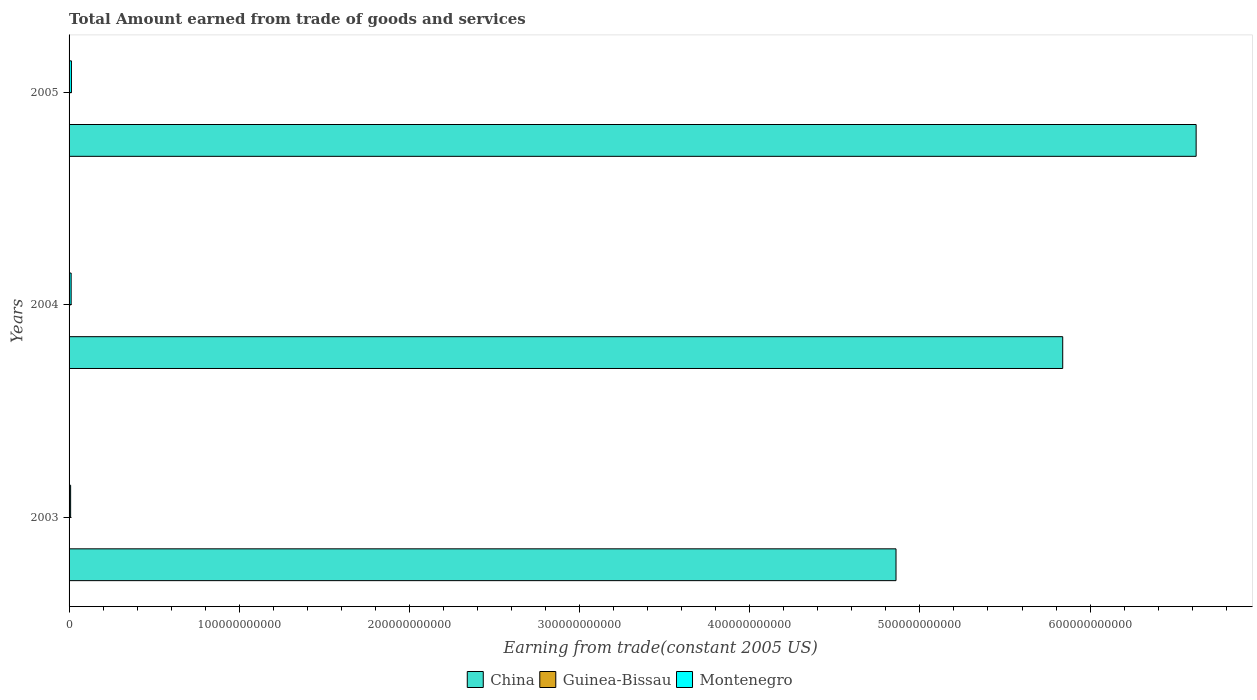How many groups of bars are there?
Give a very brief answer. 3. How many bars are there on the 3rd tick from the bottom?
Give a very brief answer. 3. In how many cases, is the number of bars for a given year not equal to the number of legend labels?
Your response must be concise. 0. What is the total amount earned by trading goods and services in Montenegro in 2005?
Your answer should be very brief. 1.38e+09. Across all years, what is the maximum total amount earned by trading goods and services in China?
Offer a terse response. 6.62e+11. Across all years, what is the minimum total amount earned by trading goods and services in Montenegro?
Make the answer very short. 9.18e+08. What is the total total amount earned by trading goods and services in Montenegro in the graph?
Offer a terse response. 3.51e+09. What is the difference between the total amount earned by trading goods and services in Montenegro in 2003 and that in 2004?
Offer a terse response. -2.95e+08. What is the difference between the total amount earned by trading goods and services in China in 2004 and the total amount earned by trading goods and services in Montenegro in 2003?
Provide a short and direct response. 5.83e+11. What is the average total amount earned by trading goods and services in Montenegro per year?
Keep it short and to the point. 1.17e+09. In the year 2003, what is the difference between the total amount earned by trading goods and services in China and total amount earned by trading goods and services in Montenegro?
Keep it short and to the point. 4.85e+11. What is the ratio of the total amount earned by trading goods and services in China in 2003 to that in 2004?
Offer a terse response. 0.83. Is the total amount earned by trading goods and services in Montenegro in 2004 less than that in 2005?
Offer a terse response. Yes. What is the difference between the highest and the second highest total amount earned by trading goods and services in Guinea-Bissau?
Offer a very short reply. 2.99e+06. What is the difference between the highest and the lowest total amount earned by trading goods and services in China?
Offer a very short reply. 1.76e+11. In how many years, is the total amount earned by trading goods and services in Guinea-Bissau greater than the average total amount earned by trading goods and services in Guinea-Bissau taken over all years?
Offer a terse response. 2. What does the 2nd bar from the top in 2005 represents?
Keep it short and to the point. Guinea-Bissau. What does the 3rd bar from the bottom in 2004 represents?
Offer a very short reply. Montenegro. Are all the bars in the graph horizontal?
Keep it short and to the point. Yes. What is the difference between two consecutive major ticks on the X-axis?
Your response must be concise. 1.00e+11. Where does the legend appear in the graph?
Offer a very short reply. Bottom center. How many legend labels are there?
Keep it short and to the point. 3. How are the legend labels stacked?
Offer a terse response. Horizontal. What is the title of the graph?
Provide a succinct answer. Total Amount earned from trade of goods and services. What is the label or title of the X-axis?
Provide a short and direct response. Earning from trade(constant 2005 US). What is the label or title of the Y-axis?
Give a very brief answer. Years. What is the Earning from trade(constant 2005 US) in China in 2003?
Provide a succinct answer. 4.86e+11. What is the Earning from trade(constant 2005 US) in Guinea-Bissau in 2003?
Provide a short and direct response. 1.31e+08. What is the Earning from trade(constant 2005 US) in Montenegro in 2003?
Ensure brevity in your answer.  9.18e+08. What is the Earning from trade(constant 2005 US) in China in 2004?
Your response must be concise. 5.84e+11. What is the Earning from trade(constant 2005 US) of Guinea-Bissau in 2004?
Offer a terse response. 1.71e+08. What is the Earning from trade(constant 2005 US) of Montenegro in 2004?
Ensure brevity in your answer.  1.21e+09. What is the Earning from trade(constant 2005 US) of China in 2005?
Your answer should be very brief. 6.62e+11. What is the Earning from trade(constant 2005 US) in Guinea-Bissau in 2005?
Ensure brevity in your answer.  1.68e+08. What is the Earning from trade(constant 2005 US) of Montenegro in 2005?
Offer a terse response. 1.38e+09. Across all years, what is the maximum Earning from trade(constant 2005 US) in China?
Provide a succinct answer. 6.62e+11. Across all years, what is the maximum Earning from trade(constant 2005 US) in Guinea-Bissau?
Your answer should be compact. 1.71e+08. Across all years, what is the maximum Earning from trade(constant 2005 US) of Montenegro?
Provide a succinct answer. 1.38e+09. Across all years, what is the minimum Earning from trade(constant 2005 US) of China?
Offer a terse response. 4.86e+11. Across all years, what is the minimum Earning from trade(constant 2005 US) of Guinea-Bissau?
Offer a very short reply. 1.31e+08. Across all years, what is the minimum Earning from trade(constant 2005 US) in Montenegro?
Keep it short and to the point. 9.18e+08. What is the total Earning from trade(constant 2005 US) in China in the graph?
Your answer should be very brief. 1.73e+12. What is the total Earning from trade(constant 2005 US) of Guinea-Bissau in the graph?
Provide a succinct answer. 4.70e+08. What is the total Earning from trade(constant 2005 US) of Montenegro in the graph?
Provide a succinct answer. 3.51e+09. What is the difference between the Earning from trade(constant 2005 US) of China in 2003 and that in 2004?
Keep it short and to the point. -9.80e+1. What is the difference between the Earning from trade(constant 2005 US) of Guinea-Bissau in 2003 and that in 2004?
Your answer should be compact. -3.94e+07. What is the difference between the Earning from trade(constant 2005 US) in Montenegro in 2003 and that in 2004?
Give a very brief answer. -2.95e+08. What is the difference between the Earning from trade(constant 2005 US) in China in 2003 and that in 2005?
Your response must be concise. -1.76e+11. What is the difference between the Earning from trade(constant 2005 US) in Guinea-Bissau in 2003 and that in 2005?
Provide a short and direct response. -3.64e+07. What is the difference between the Earning from trade(constant 2005 US) in Montenegro in 2003 and that in 2005?
Your answer should be compact. -4.61e+08. What is the difference between the Earning from trade(constant 2005 US) of China in 2004 and that in 2005?
Provide a short and direct response. -7.84e+1. What is the difference between the Earning from trade(constant 2005 US) in Guinea-Bissau in 2004 and that in 2005?
Offer a very short reply. 2.99e+06. What is the difference between the Earning from trade(constant 2005 US) in Montenegro in 2004 and that in 2005?
Your answer should be compact. -1.66e+08. What is the difference between the Earning from trade(constant 2005 US) in China in 2003 and the Earning from trade(constant 2005 US) in Guinea-Bissau in 2004?
Keep it short and to the point. 4.86e+11. What is the difference between the Earning from trade(constant 2005 US) of China in 2003 and the Earning from trade(constant 2005 US) of Montenegro in 2004?
Make the answer very short. 4.85e+11. What is the difference between the Earning from trade(constant 2005 US) of Guinea-Bissau in 2003 and the Earning from trade(constant 2005 US) of Montenegro in 2004?
Offer a very short reply. -1.08e+09. What is the difference between the Earning from trade(constant 2005 US) of China in 2003 and the Earning from trade(constant 2005 US) of Guinea-Bissau in 2005?
Offer a terse response. 4.86e+11. What is the difference between the Earning from trade(constant 2005 US) of China in 2003 and the Earning from trade(constant 2005 US) of Montenegro in 2005?
Your answer should be compact. 4.85e+11. What is the difference between the Earning from trade(constant 2005 US) of Guinea-Bissau in 2003 and the Earning from trade(constant 2005 US) of Montenegro in 2005?
Give a very brief answer. -1.25e+09. What is the difference between the Earning from trade(constant 2005 US) in China in 2004 and the Earning from trade(constant 2005 US) in Guinea-Bissau in 2005?
Provide a short and direct response. 5.84e+11. What is the difference between the Earning from trade(constant 2005 US) in China in 2004 and the Earning from trade(constant 2005 US) in Montenegro in 2005?
Offer a very short reply. 5.83e+11. What is the difference between the Earning from trade(constant 2005 US) of Guinea-Bissau in 2004 and the Earning from trade(constant 2005 US) of Montenegro in 2005?
Give a very brief answer. -1.21e+09. What is the average Earning from trade(constant 2005 US) in China per year?
Offer a very short reply. 5.77e+11. What is the average Earning from trade(constant 2005 US) in Guinea-Bissau per year?
Keep it short and to the point. 1.57e+08. What is the average Earning from trade(constant 2005 US) of Montenegro per year?
Your answer should be very brief. 1.17e+09. In the year 2003, what is the difference between the Earning from trade(constant 2005 US) in China and Earning from trade(constant 2005 US) in Guinea-Bissau?
Give a very brief answer. 4.86e+11. In the year 2003, what is the difference between the Earning from trade(constant 2005 US) in China and Earning from trade(constant 2005 US) in Montenegro?
Ensure brevity in your answer.  4.85e+11. In the year 2003, what is the difference between the Earning from trade(constant 2005 US) in Guinea-Bissau and Earning from trade(constant 2005 US) in Montenegro?
Offer a terse response. -7.86e+08. In the year 2004, what is the difference between the Earning from trade(constant 2005 US) of China and Earning from trade(constant 2005 US) of Guinea-Bissau?
Your response must be concise. 5.84e+11. In the year 2004, what is the difference between the Earning from trade(constant 2005 US) in China and Earning from trade(constant 2005 US) in Montenegro?
Provide a succinct answer. 5.83e+11. In the year 2004, what is the difference between the Earning from trade(constant 2005 US) in Guinea-Bissau and Earning from trade(constant 2005 US) in Montenegro?
Offer a very short reply. -1.04e+09. In the year 2005, what is the difference between the Earning from trade(constant 2005 US) of China and Earning from trade(constant 2005 US) of Guinea-Bissau?
Your answer should be compact. 6.62e+11. In the year 2005, what is the difference between the Earning from trade(constant 2005 US) in China and Earning from trade(constant 2005 US) in Montenegro?
Ensure brevity in your answer.  6.61e+11. In the year 2005, what is the difference between the Earning from trade(constant 2005 US) of Guinea-Bissau and Earning from trade(constant 2005 US) of Montenegro?
Offer a very short reply. -1.21e+09. What is the ratio of the Earning from trade(constant 2005 US) in China in 2003 to that in 2004?
Offer a very short reply. 0.83. What is the ratio of the Earning from trade(constant 2005 US) of Guinea-Bissau in 2003 to that in 2004?
Keep it short and to the point. 0.77. What is the ratio of the Earning from trade(constant 2005 US) of Montenegro in 2003 to that in 2004?
Ensure brevity in your answer.  0.76. What is the ratio of the Earning from trade(constant 2005 US) of China in 2003 to that in 2005?
Give a very brief answer. 0.73. What is the ratio of the Earning from trade(constant 2005 US) in Guinea-Bissau in 2003 to that in 2005?
Your answer should be compact. 0.78. What is the ratio of the Earning from trade(constant 2005 US) of Montenegro in 2003 to that in 2005?
Give a very brief answer. 0.67. What is the ratio of the Earning from trade(constant 2005 US) of China in 2004 to that in 2005?
Give a very brief answer. 0.88. What is the ratio of the Earning from trade(constant 2005 US) in Guinea-Bissau in 2004 to that in 2005?
Your answer should be very brief. 1.02. What is the ratio of the Earning from trade(constant 2005 US) in Montenegro in 2004 to that in 2005?
Offer a very short reply. 0.88. What is the difference between the highest and the second highest Earning from trade(constant 2005 US) of China?
Provide a short and direct response. 7.84e+1. What is the difference between the highest and the second highest Earning from trade(constant 2005 US) of Guinea-Bissau?
Provide a succinct answer. 2.99e+06. What is the difference between the highest and the second highest Earning from trade(constant 2005 US) of Montenegro?
Your response must be concise. 1.66e+08. What is the difference between the highest and the lowest Earning from trade(constant 2005 US) in China?
Provide a short and direct response. 1.76e+11. What is the difference between the highest and the lowest Earning from trade(constant 2005 US) of Guinea-Bissau?
Provide a succinct answer. 3.94e+07. What is the difference between the highest and the lowest Earning from trade(constant 2005 US) in Montenegro?
Give a very brief answer. 4.61e+08. 